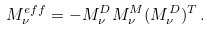<formula> <loc_0><loc_0><loc_500><loc_500>M _ { \nu } ^ { e f f } = - M _ { \nu } ^ { D } M _ { \nu } ^ { M } ( M _ { \nu } ^ { D } ) ^ { T } \, .</formula> 